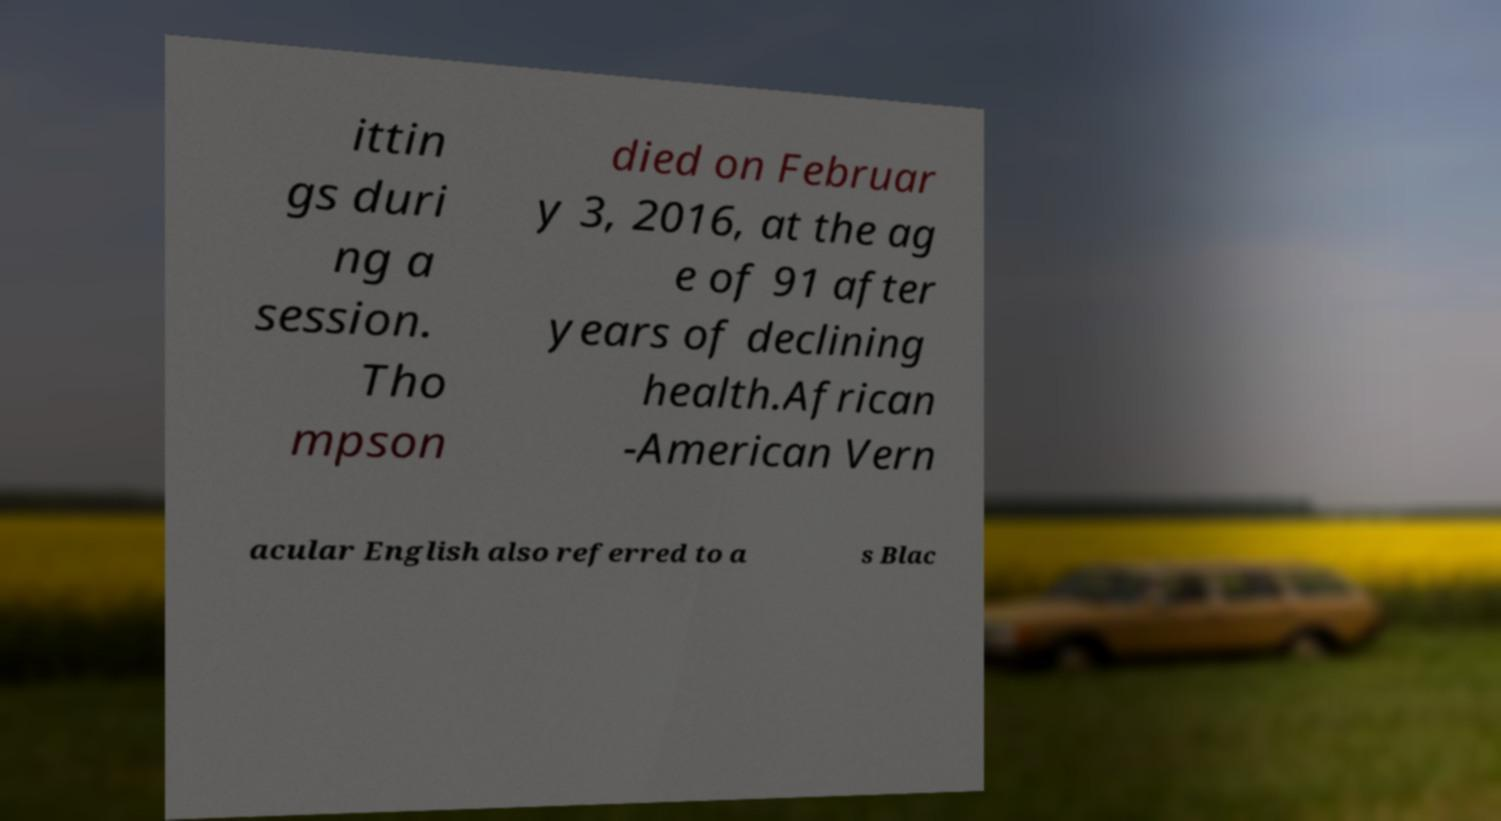For documentation purposes, I need the text within this image transcribed. Could you provide that? ittin gs duri ng a session. Tho mpson died on Februar y 3, 2016, at the ag e of 91 after years of declining health.African -American Vern acular English also referred to a s Blac 